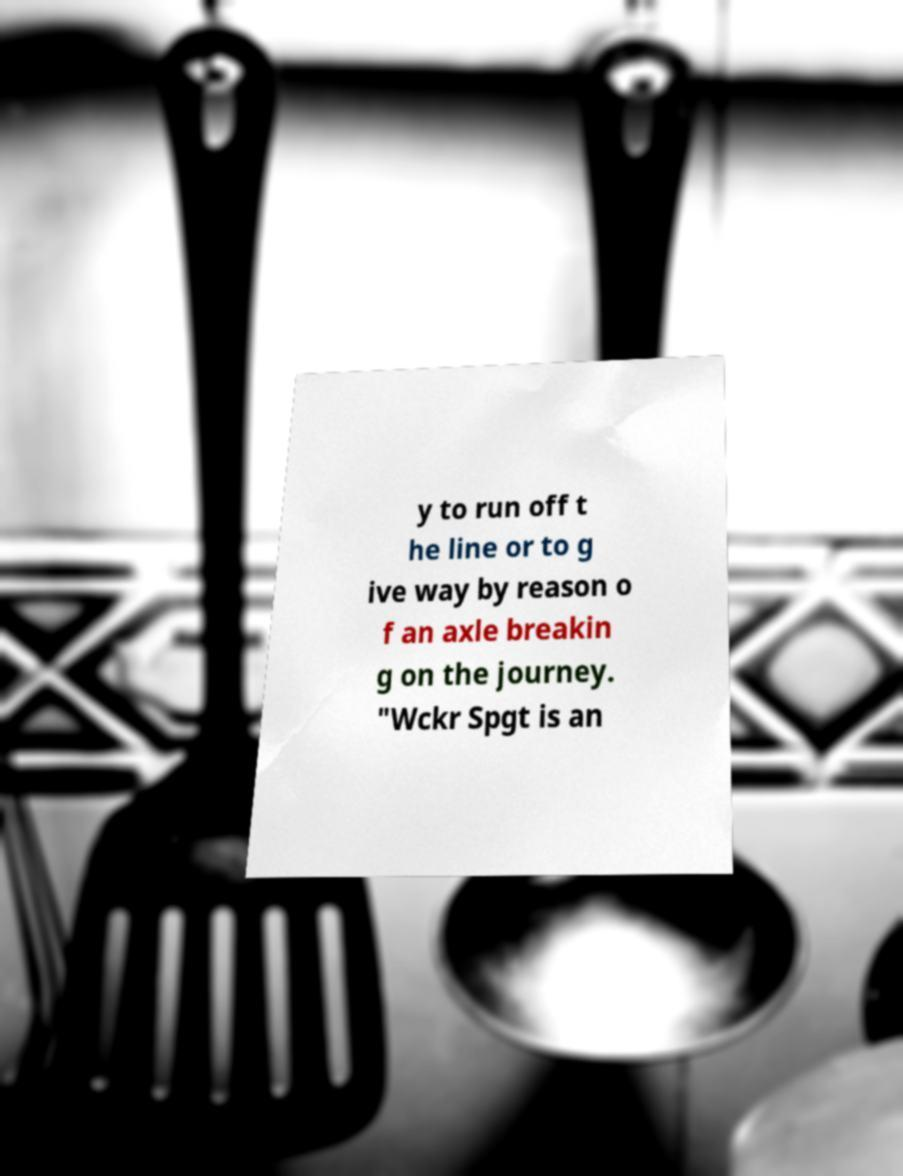There's text embedded in this image that I need extracted. Can you transcribe it verbatim? y to run off t he line or to g ive way by reason o f an axle breakin g on the journey. "Wckr Spgt is an 